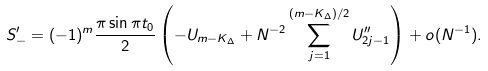<formula> <loc_0><loc_0><loc_500><loc_500>S _ { - } ^ { \prime } = ( - 1 ) ^ { m } \frac { \pi \sin \pi t _ { 0 } } { 2 } \left ( - U _ { m - K _ { \Delta } } + N ^ { - 2 } \sum _ { j = 1 } ^ { ( m - K _ { \Delta } ) / 2 } U _ { 2 j - 1 } ^ { \prime \prime } \right ) + o ( N ^ { - 1 } ) .</formula> 